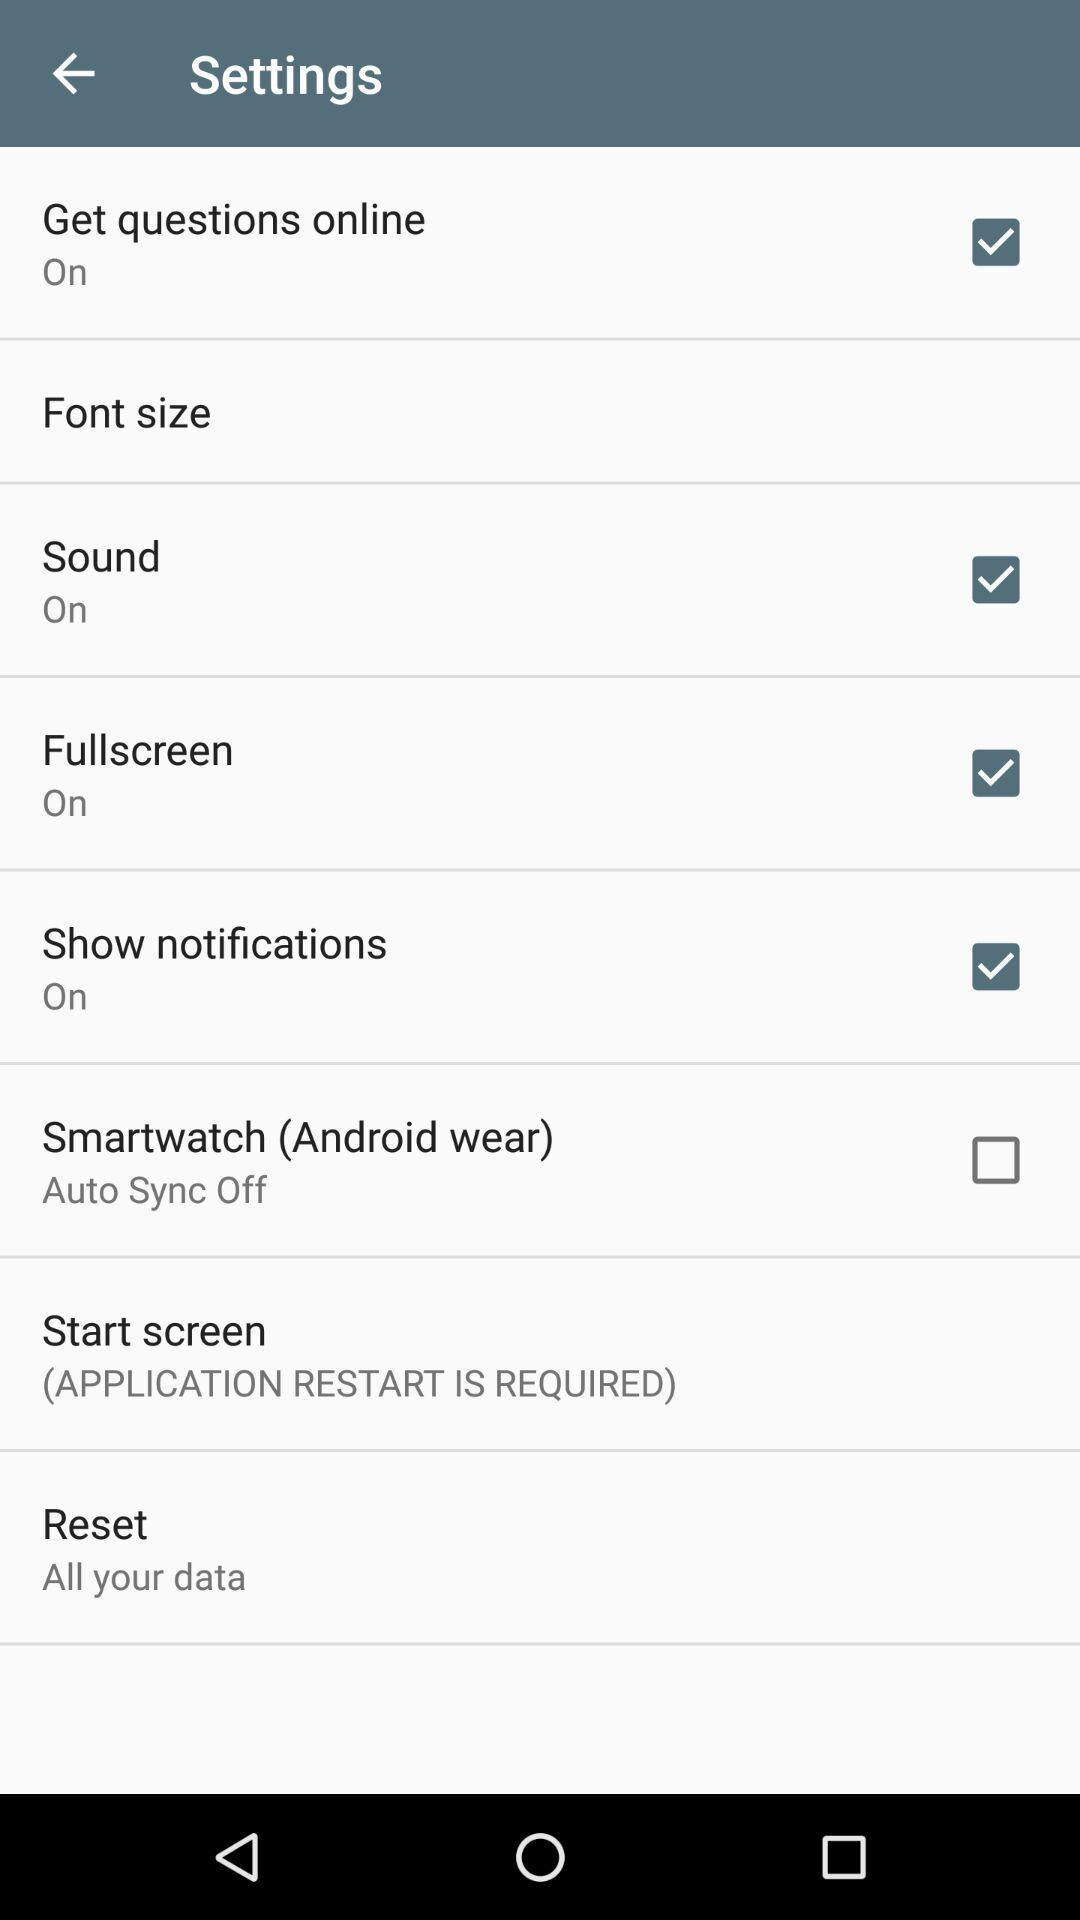What is the status of "Smartwatch (Android wear)"? The status is "off". 